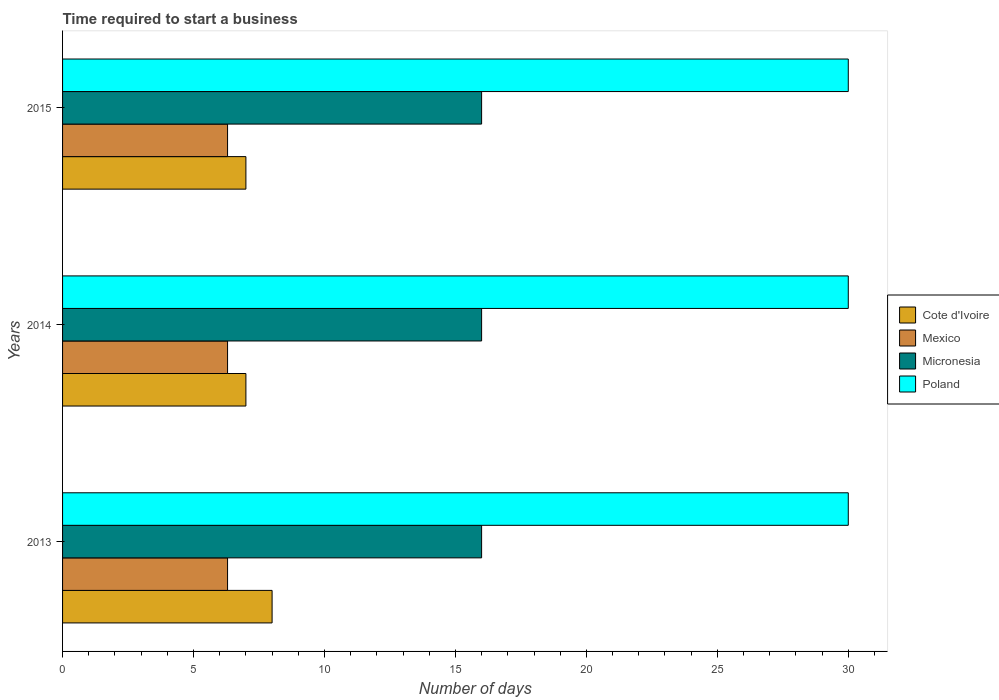How many different coloured bars are there?
Ensure brevity in your answer.  4. Are the number of bars per tick equal to the number of legend labels?
Provide a short and direct response. Yes. Are the number of bars on each tick of the Y-axis equal?
Provide a short and direct response. Yes. How many bars are there on the 3rd tick from the bottom?
Provide a succinct answer. 4. What is the number of days required to start a business in Poland in 2015?
Your response must be concise. 30. Across all years, what is the maximum number of days required to start a business in Poland?
Keep it short and to the point. 30. Across all years, what is the minimum number of days required to start a business in Poland?
Give a very brief answer. 30. In which year was the number of days required to start a business in Poland maximum?
Ensure brevity in your answer.  2013. In which year was the number of days required to start a business in Poland minimum?
Your answer should be compact. 2013. What is the total number of days required to start a business in Mexico in the graph?
Keep it short and to the point. 18.9. What is the difference between the number of days required to start a business in Mexico in 2014 and the number of days required to start a business in Poland in 2013?
Your response must be concise. -23.7. In the year 2015, what is the difference between the number of days required to start a business in Mexico and number of days required to start a business in Cote d'Ivoire?
Keep it short and to the point. -0.7. What is the difference between the highest and the second highest number of days required to start a business in Cote d'Ivoire?
Keep it short and to the point. 1. Is the sum of the number of days required to start a business in Poland in 2013 and 2014 greater than the maximum number of days required to start a business in Cote d'Ivoire across all years?
Your answer should be compact. Yes. What does the 2nd bar from the top in 2013 represents?
Your response must be concise. Micronesia. Is it the case that in every year, the sum of the number of days required to start a business in Cote d'Ivoire and number of days required to start a business in Mexico is greater than the number of days required to start a business in Poland?
Your response must be concise. No. Are the values on the major ticks of X-axis written in scientific E-notation?
Make the answer very short. No. What is the title of the graph?
Your answer should be compact. Time required to start a business. Does "Greenland" appear as one of the legend labels in the graph?
Offer a terse response. No. What is the label or title of the X-axis?
Your answer should be compact. Number of days. What is the label or title of the Y-axis?
Keep it short and to the point. Years. What is the Number of days in Cote d'Ivoire in 2013?
Offer a terse response. 8. What is the Number of days in Poland in 2013?
Keep it short and to the point. 30. What is the Number of days in Cote d'Ivoire in 2014?
Your answer should be compact. 7. What is the Number of days in Mexico in 2014?
Ensure brevity in your answer.  6.3. What is the Number of days in Micronesia in 2014?
Ensure brevity in your answer.  16. What is the Number of days in Poland in 2014?
Give a very brief answer. 30. What is the Number of days in Micronesia in 2015?
Make the answer very short. 16. Across all years, what is the maximum Number of days of Micronesia?
Give a very brief answer. 16. Across all years, what is the minimum Number of days of Cote d'Ivoire?
Your answer should be compact. 7. Across all years, what is the minimum Number of days of Mexico?
Provide a succinct answer. 6.3. Across all years, what is the minimum Number of days of Poland?
Offer a very short reply. 30. What is the total Number of days in Mexico in the graph?
Provide a succinct answer. 18.9. What is the total Number of days in Micronesia in the graph?
Offer a terse response. 48. What is the total Number of days in Poland in the graph?
Your answer should be very brief. 90. What is the difference between the Number of days in Micronesia in 2013 and that in 2014?
Your answer should be very brief. 0. What is the difference between the Number of days in Poland in 2013 and that in 2014?
Offer a terse response. 0. What is the difference between the Number of days of Cote d'Ivoire in 2013 and that in 2015?
Provide a short and direct response. 1. What is the difference between the Number of days in Poland in 2013 and that in 2015?
Provide a succinct answer. 0. What is the difference between the Number of days of Cote d'Ivoire in 2014 and that in 2015?
Your response must be concise. 0. What is the difference between the Number of days of Poland in 2014 and that in 2015?
Offer a very short reply. 0. What is the difference between the Number of days in Mexico in 2013 and the Number of days in Poland in 2014?
Give a very brief answer. -23.7. What is the difference between the Number of days of Cote d'Ivoire in 2013 and the Number of days of Micronesia in 2015?
Provide a succinct answer. -8. What is the difference between the Number of days in Cote d'Ivoire in 2013 and the Number of days in Poland in 2015?
Your response must be concise. -22. What is the difference between the Number of days in Mexico in 2013 and the Number of days in Poland in 2015?
Keep it short and to the point. -23.7. What is the difference between the Number of days of Cote d'Ivoire in 2014 and the Number of days of Micronesia in 2015?
Your answer should be very brief. -9. What is the difference between the Number of days in Mexico in 2014 and the Number of days in Micronesia in 2015?
Your response must be concise. -9.7. What is the difference between the Number of days of Mexico in 2014 and the Number of days of Poland in 2015?
Provide a short and direct response. -23.7. What is the average Number of days of Cote d'Ivoire per year?
Provide a succinct answer. 7.33. What is the average Number of days in Mexico per year?
Provide a succinct answer. 6.3. What is the average Number of days in Micronesia per year?
Give a very brief answer. 16. In the year 2013, what is the difference between the Number of days in Cote d'Ivoire and Number of days in Mexico?
Give a very brief answer. 1.7. In the year 2013, what is the difference between the Number of days of Cote d'Ivoire and Number of days of Poland?
Give a very brief answer. -22. In the year 2013, what is the difference between the Number of days of Mexico and Number of days of Micronesia?
Offer a terse response. -9.7. In the year 2013, what is the difference between the Number of days of Mexico and Number of days of Poland?
Provide a short and direct response. -23.7. In the year 2013, what is the difference between the Number of days in Micronesia and Number of days in Poland?
Offer a very short reply. -14. In the year 2014, what is the difference between the Number of days in Cote d'Ivoire and Number of days in Micronesia?
Your response must be concise. -9. In the year 2014, what is the difference between the Number of days in Mexico and Number of days in Poland?
Offer a very short reply. -23.7. In the year 2015, what is the difference between the Number of days in Cote d'Ivoire and Number of days in Mexico?
Offer a very short reply. 0.7. In the year 2015, what is the difference between the Number of days of Cote d'Ivoire and Number of days of Poland?
Provide a short and direct response. -23. In the year 2015, what is the difference between the Number of days of Mexico and Number of days of Micronesia?
Give a very brief answer. -9.7. In the year 2015, what is the difference between the Number of days in Mexico and Number of days in Poland?
Offer a very short reply. -23.7. What is the ratio of the Number of days of Mexico in 2013 to that in 2014?
Offer a terse response. 1. What is the ratio of the Number of days of Cote d'Ivoire in 2013 to that in 2015?
Your response must be concise. 1.14. What is the ratio of the Number of days of Mexico in 2013 to that in 2015?
Your response must be concise. 1. What is the ratio of the Number of days in Cote d'Ivoire in 2014 to that in 2015?
Your answer should be compact. 1. What is the ratio of the Number of days in Micronesia in 2014 to that in 2015?
Give a very brief answer. 1. What is the ratio of the Number of days of Poland in 2014 to that in 2015?
Ensure brevity in your answer.  1. What is the difference between the highest and the lowest Number of days of Poland?
Ensure brevity in your answer.  0. 